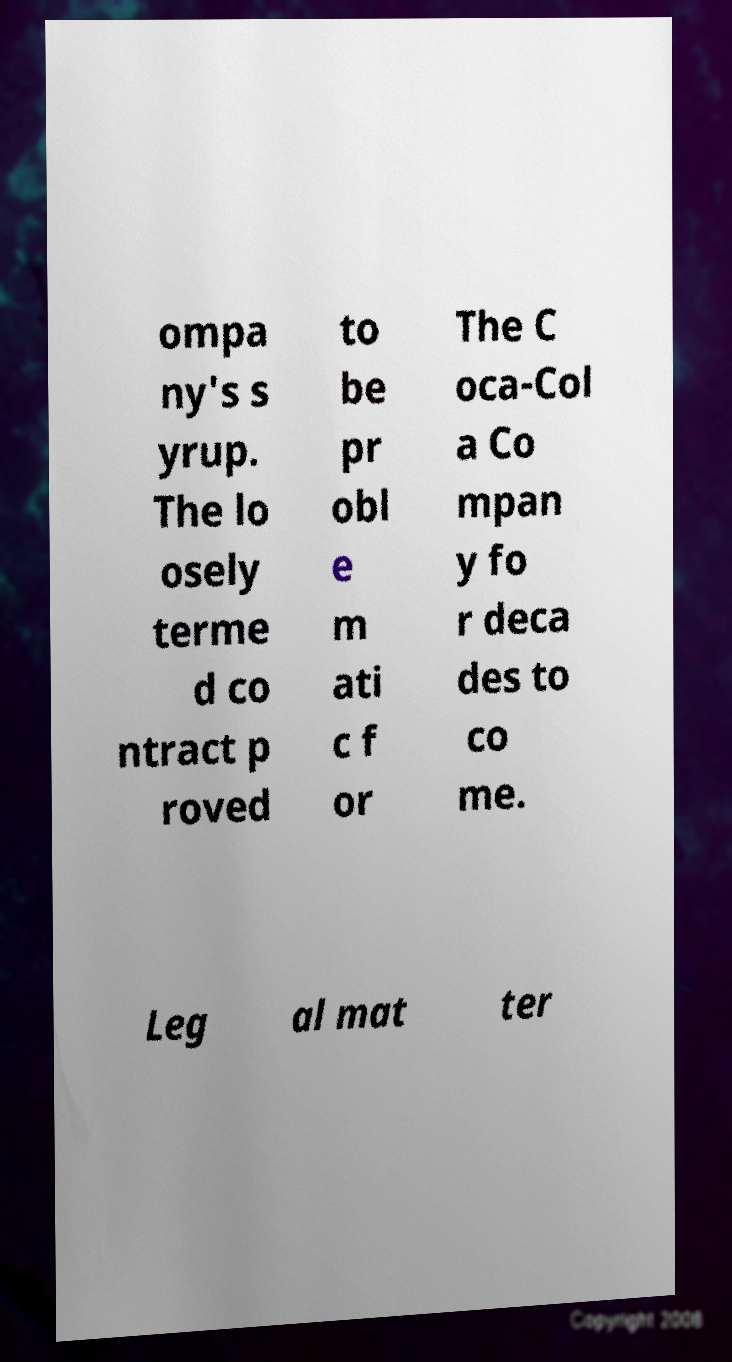Could you extract and type out the text from this image? ompa ny's s yrup. The lo osely terme d co ntract p roved to be pr obl e m ati c f or The C oca-Col a Co mpan y fo r deca des to co me. Leg al mat ter 